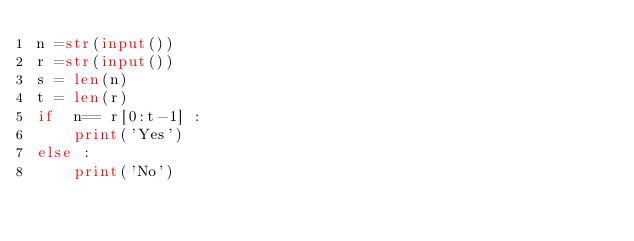Convert code to text. <code><loc_0><loc_0><loc_500><loc_500><_Python_>n =str(input())
r =str(input())
s = len(n)
t = len(r)
if  n== r[0:t-1] :
    print('Yes')
else :
    print('No')</code> 